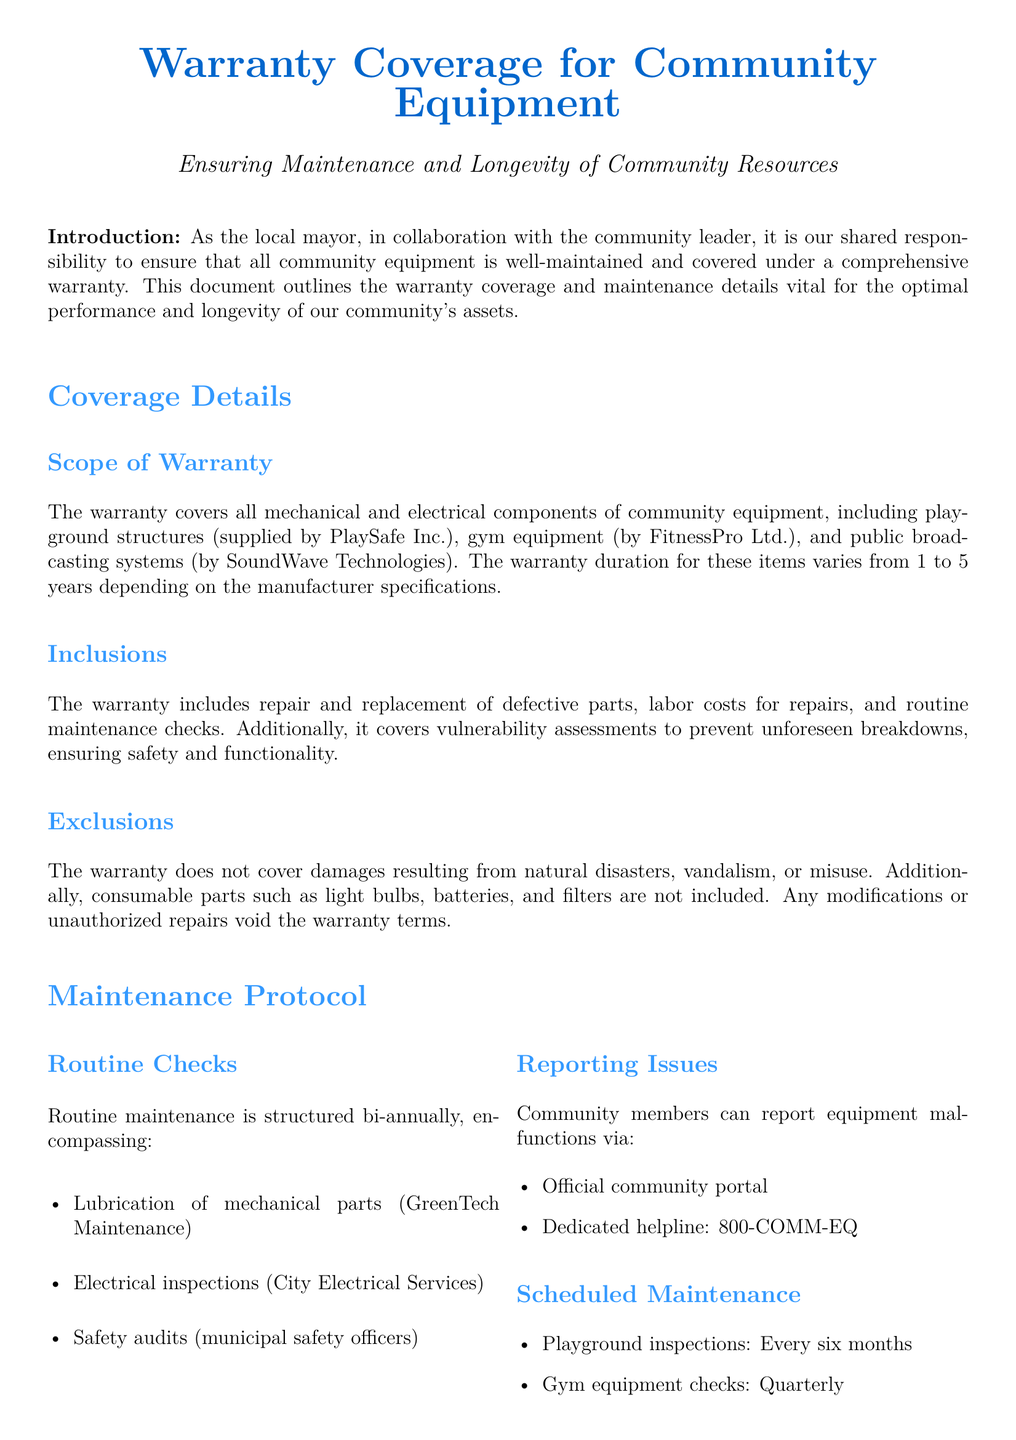What is the warranty duration for playground structures? The warranty duration for playground structures supplied by PlaySafe Inc. is 5 years.
Answer: 5 years What types of maintenance checks are performed bi-annually? Routine maintenance checks include lubrication of mechanical parts, electrical inspections, and safety audits.
Answer: Lubrication, inspections, audits Which company supplies gym equipment? The gym equipment is supplied by FitnessPro Ltd.
Answer: FitnessPro Ltd What is the dedicated helpline for reporting equipment malfunctions? The dedicated helpline for reporting equipment malfunctions is 800-COMM-EQ.
Answer: 800-COMM-EQ What does the warranty exclude? The warranty does not cover damages from natural disasters, vandalism, misuse, and consumable parts.
Answer: Natural disasters, vandalism, misuse, consumable parts How often are playground inspections scheduled? Playground inspections are scheduled every six months.
Answer: Every six months What is the support email for PlaySafe Inc.? The support email for PlaySafe Inc. is support@playsafe.com.
Answer: support@playsafe.com How can community members report issues? Community members can report issues via the official community portal or the dedicated helpline.
Answer: Official community portal, helpline What is the warranty period for public broadcasting systems? The warranty period for public broadcasting systems supplied by SoundWave Technologies is 2 years.
Answer: 2 years 